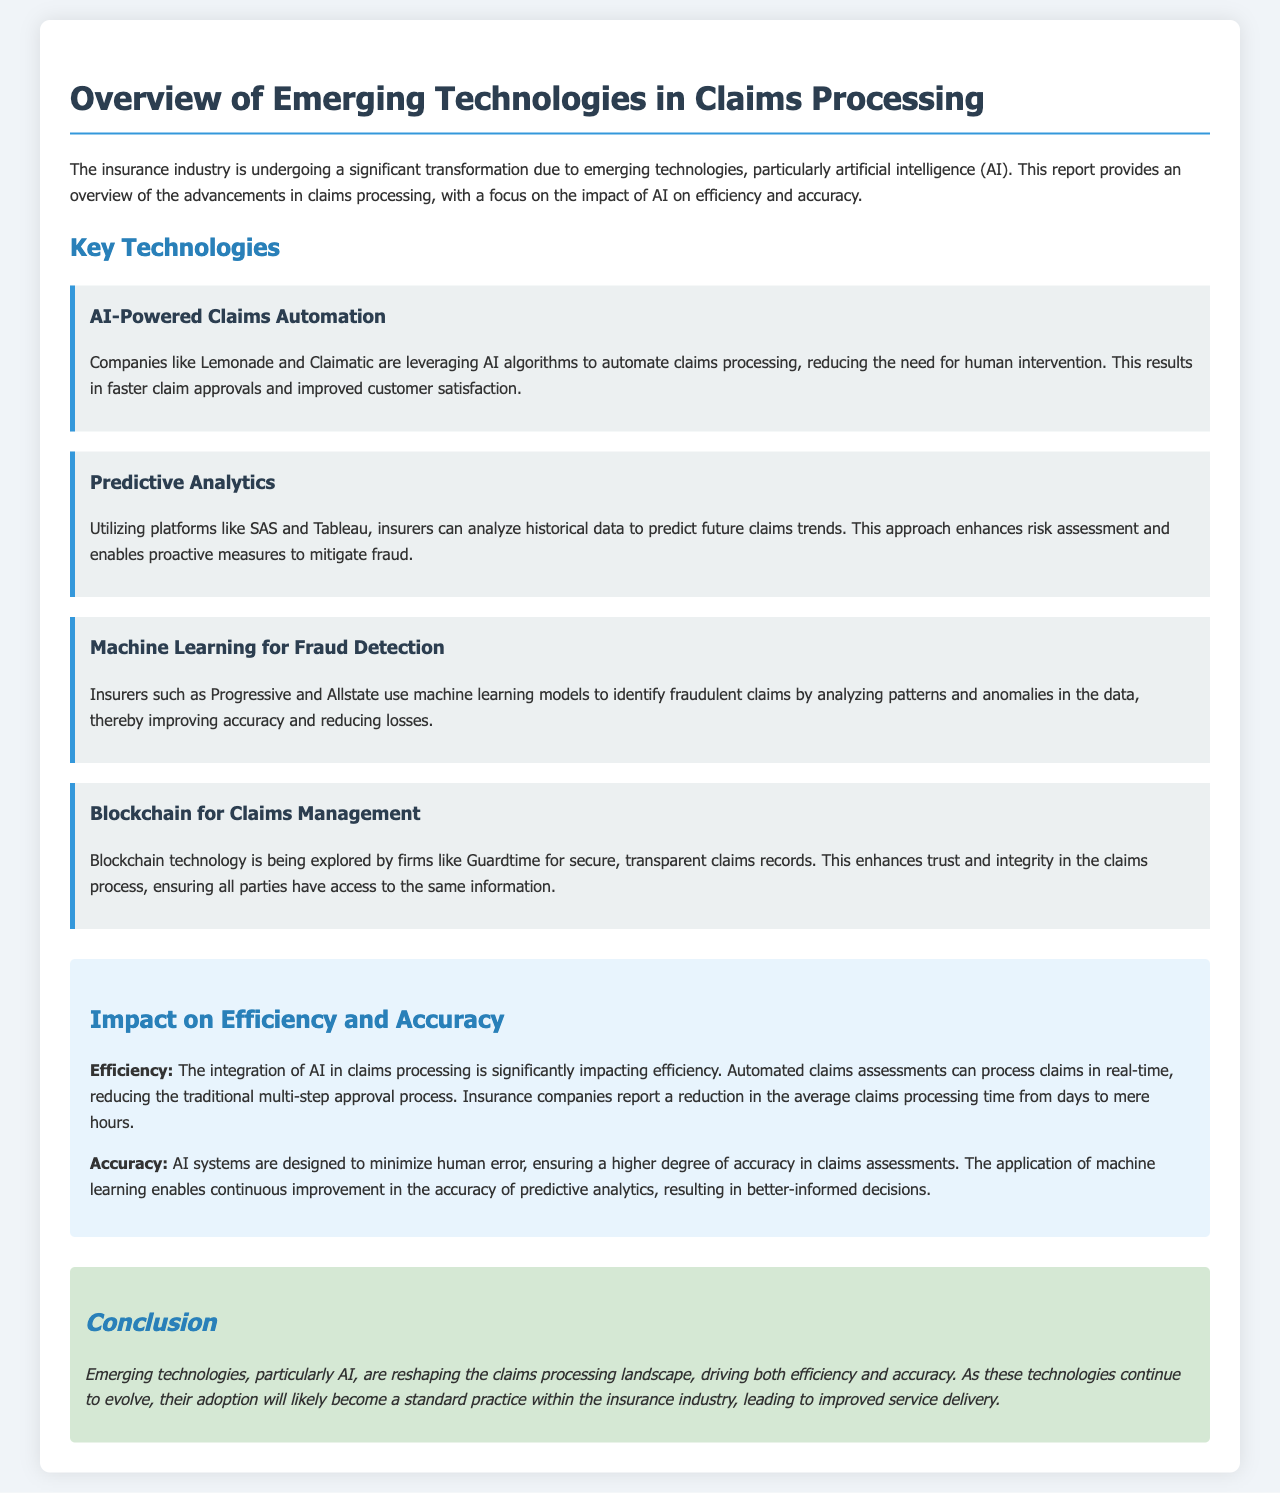What are some companies leveraging AI for claims processing automation? The document mentions Lemonade and Claimatic as companies using AI algorithms for automating claims processing.
Answer: Lemonade, Claimatic What technology is used by insurers for fraud detection? The document specifies that machine learning models are employed by insurers for identifying fraudulent claims.
Answer: Machine learning What platforms are used for predictive analytics in insurance? The report highlights that platforms like SAS and Tableau are utilized for predicting future claims trends.
Answer: SAS, Tableau What is the impact of AI on claims processing time? The document states that there is a reduction in the average claims processing time from days to mere hours due to AI integration.
Answer: From days to hours Which technology enhances trust in claims management? The report points out that blockchain technology is being explored to enhance trust and integrity in claims records.
Answer: Blockchain What is the key benefit of AI systems in claims assessments? The document emphasizes that AI systems are designed to minimize human error, ensuring higher accuracy in assessments.
Answer: Minimize human error How does machine learning contribute to accuracy in claims processing? The document mentions that machine learning enables continuous improvement in accuracy of predictive analytics.
Answer: Continuous improvement What is the overall conclusion regarding emerging technologies in claims processing? The report concludes that emerging technologies, particularly AI, are reshaping the claims processing landscape, improving service delivery.
Answer: Improving service delivery 